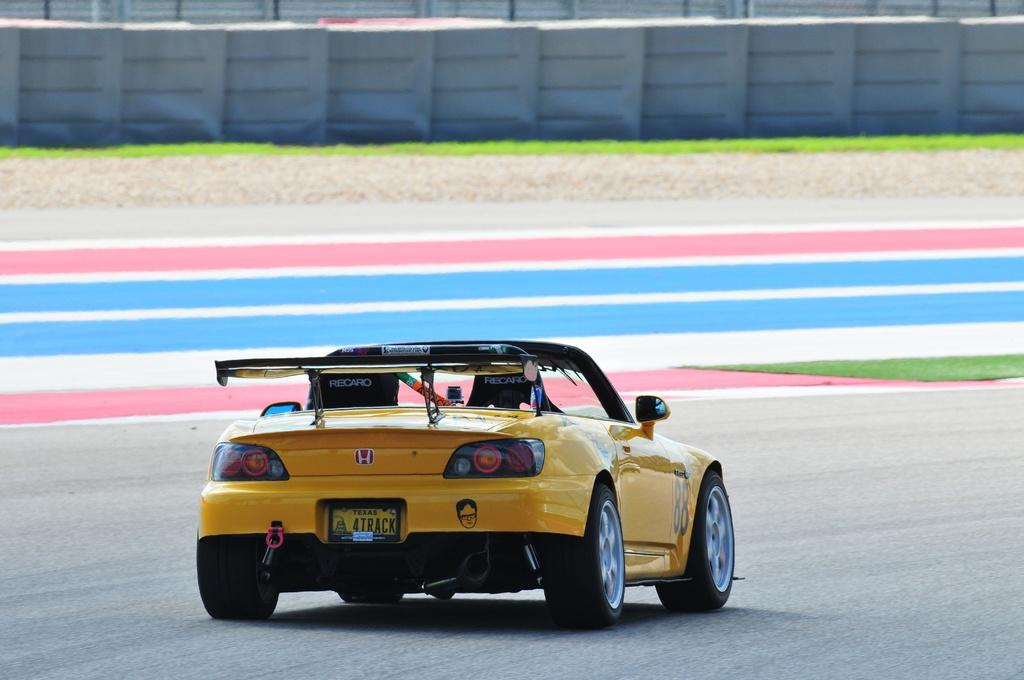What color is the car in the image? The car in the image is yellow and black. Where is the car located in the image? The car is on the road in the image. What type of flooring is visible in the image? There is a colorful floor visible in the image. What kind of fencing is present in the image? There is ash fencing in the image. What type of fruit is being served by the maid in the image? There is no maid or fruit present in the image. How many ducks are visible in the image? There are no ducks present in the image. 